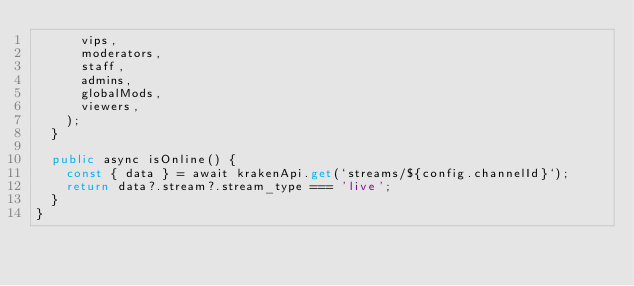Convert code to text. <code><loc_0><loc_0><loc_500><loc_500><_TypeScript_>      vips,
      moderators,
      staff,
      admins,
      globalMods,
      viewers,
    );
  }

  public async isOnline() {
    const { data } = await krakenApi.get(`streams/${config.channelId}`);
    return data?.stream?.stream_type === 'live';
  }
}
</code> 